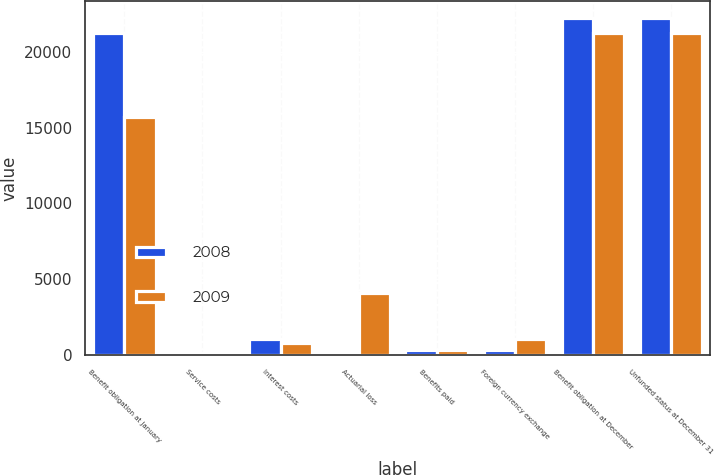Convert chart to OTSL. <chart><loc_0><loc_0><loc_500><loc_500><stacked_bar_chart><ecel><fcel>Benefit obligation at January<fcel>Service costs<fcel>Interest costs<fcel>Actuarial loss<fcel>Benefits paid<fcel>Foreign currency exchange<fcel>Benefit obligation at December<fcel>Unfunded status at December 31<nl><fcel>2008<fcel>21237<fcel>125<fcel>1085<fcel>219<fcel>353<fcel>345<fcel>22220<fcel>22220<nl><fcel>2009<fcel>15718<fcel>153<fcel>820<fcel>4122<fcel>357<fcel>1051<fcel>21237<fcel>21237<nl></chart> 